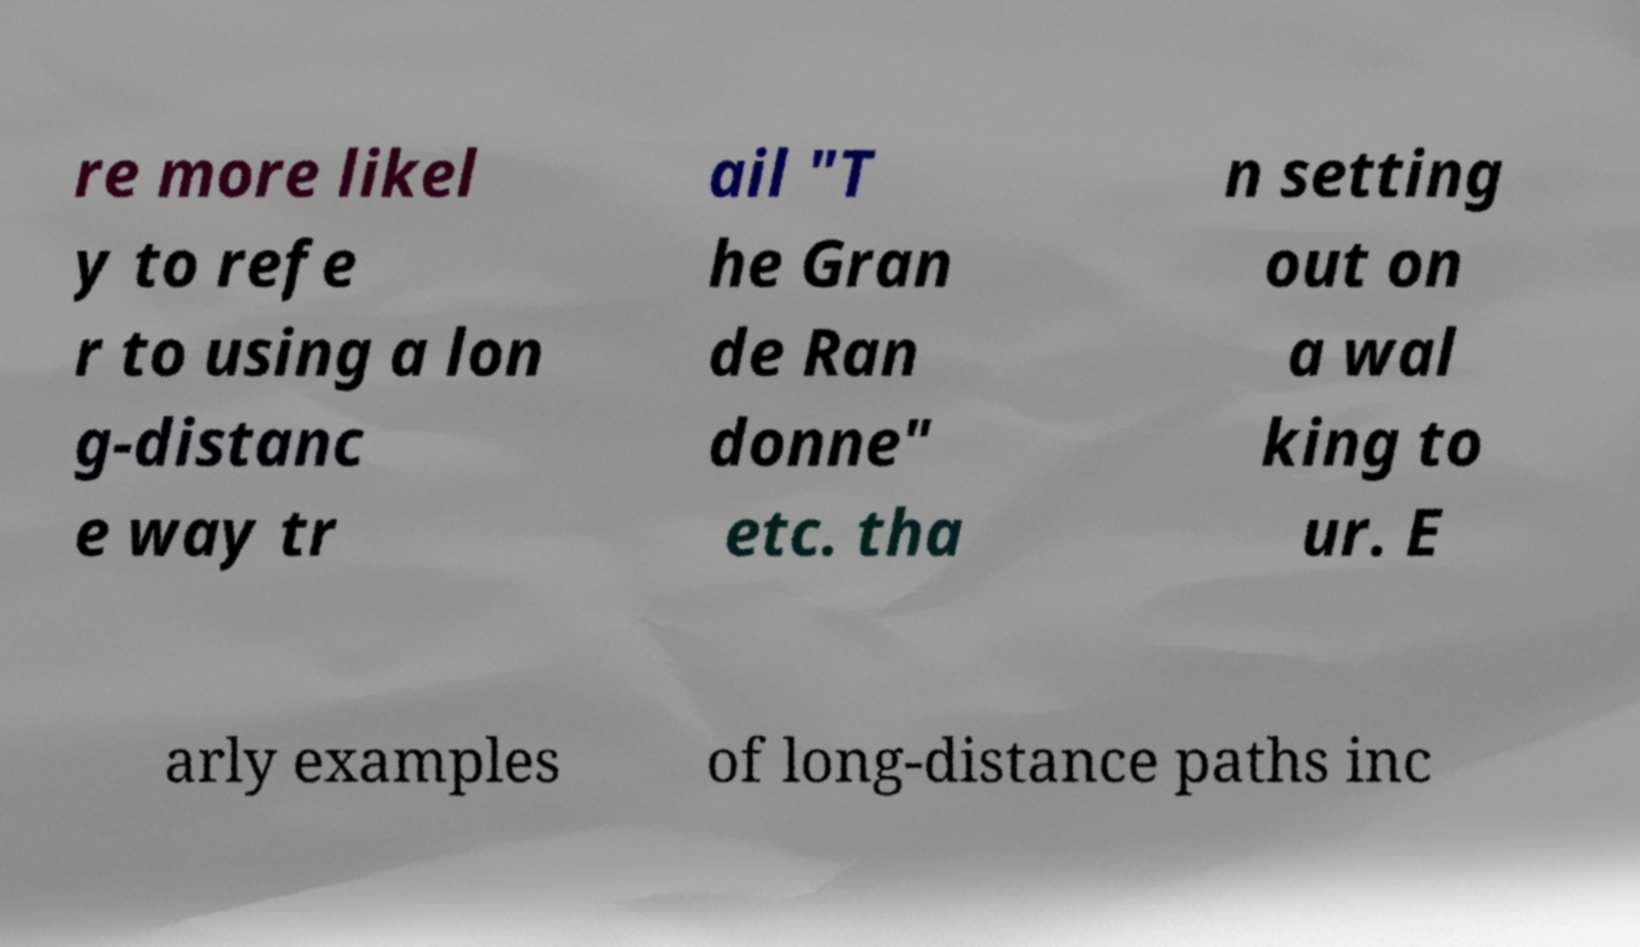Could you assist in decoding the text presented in this image and type it out clearly? re more likel y to refe r to using a lon g-distanc e way tr ail "T he Gran de Ran donne" etc. tha n setting out on a wal king to ur. E arly examples of long-distance paths inc 